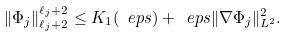Convert formula to latex. <formula><loc_0><loc_0><loc_500><loc_500>\| \Phi _ { j } \| _ { \ell _ { j } + 2 } ^ { \ell _ { j } + 2 } \leq K _ { 1 } ( \ e p s ) + \ e p s \| \nabla \Phi _ { j } \| _ { L ^ { 2 } } ^ { 2 } .</formula> 